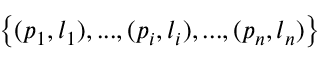<formula> <loc_0><loc_0><loc_500><loc_500>\left \{ ( p _ { 1 } , l _ { 1 } ) , \dots , ( p _ { i } , l _ { i } ) , \dots , ( p _ { n } , l _ { n } ) \right \}</formula> 